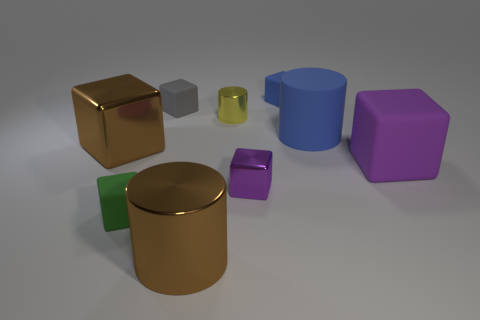Are there any large blue cylinders that have the same material as the small blue block?
Keep it short and to the point. Yes. There is a large block on the left side of the small blue block; does it have the same color as the tiny cylinder?
Provide a short and direct response. No. The purple metal object is what size?
Ensure brevity in your answer.  Small. There is a big metal object in front of the brown metallic object behind the green object; is there a big brown metal block in front of it?
Make the answer very short. No. What number of small blocks are in front of the rubber cylinder?
Give a very brief answer. 2. What number of tiny objects have the same color as the big rubber cube?
Provide a succinct answer. 1. How many objects are either big purple things on the right side of the large blue object or blue objects left of the large rubber cylinder?
Provide a short and direct response. 2. Is the number of small gray blocks greater than the number of cyan matte cylinders?
Your answer should be very brief. Yes. There is a cylinder that is in front of the small purple cube; what is its color?
Offer a very short reply. Brown. Is the shape of the tiny purple shiny object the same as the tiny gray thing?
Your answer should be compact. Yes. 